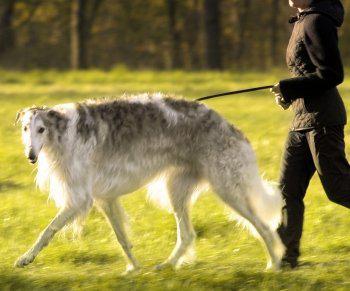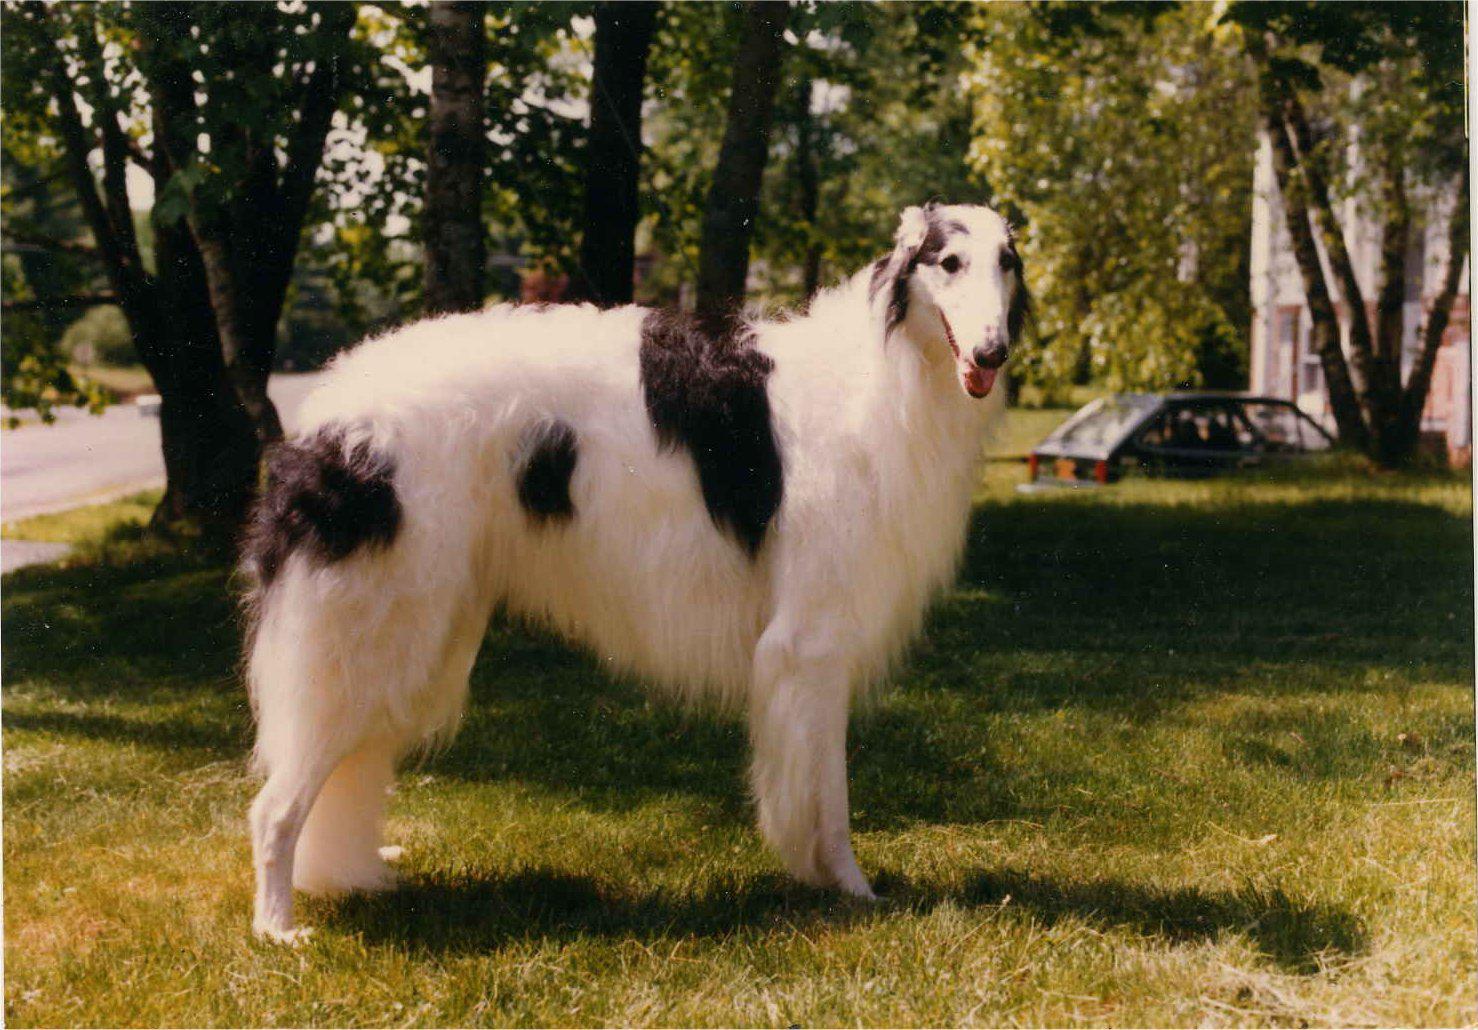The first image is the image on the left, the second image is the image on the right. Examine the images to the left and right. Is the description "there is only one human on the image." accurate? Answer yes or no. Yes. The first image is the image on the left, the second image is the image on the right. For the images shown, is this caption "Each image features one dog, and the dogs are facing opposite directions." true? Answer yes or no. Yes. 